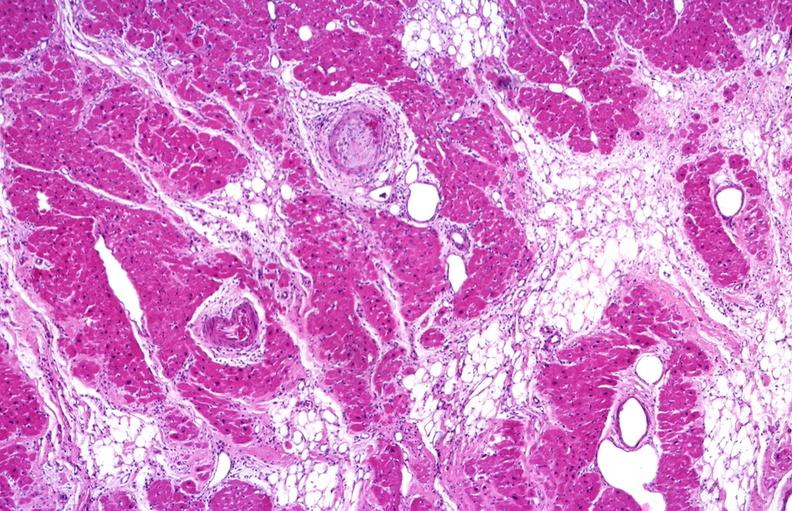s cardiovascular present?
Answer the question using a single word or phrase. Yes 